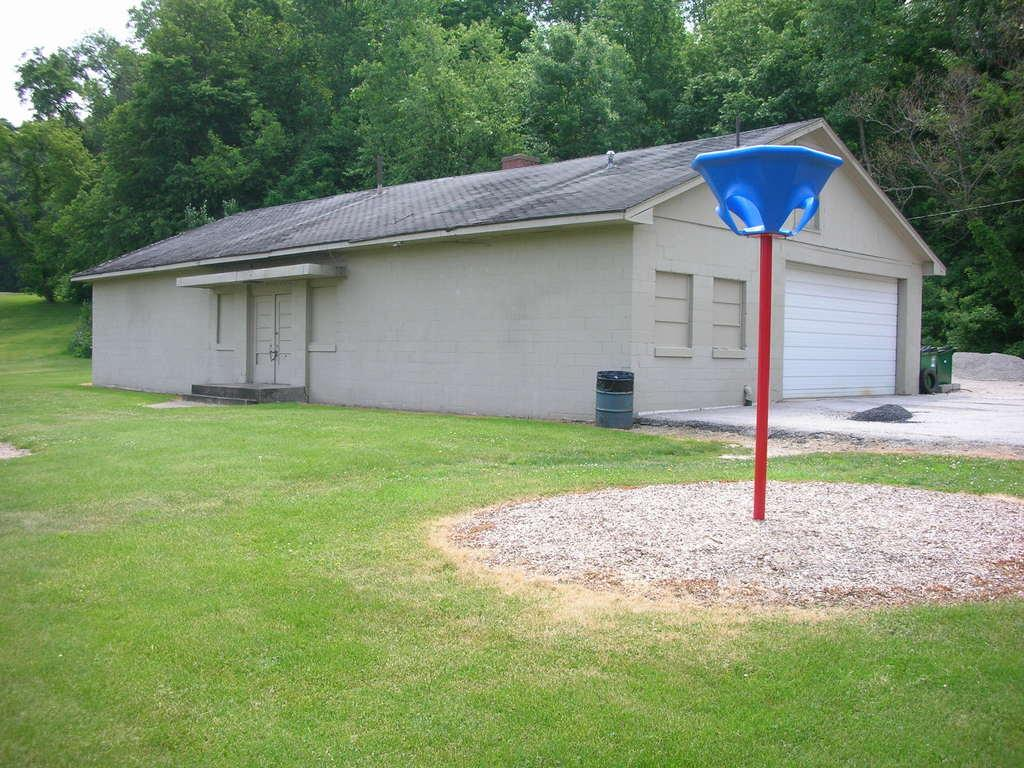What is located in the front of the image? There is a house and a pole in the front of the image. What type of vegetation is present in the front of the image? Grass is present in the front of the image. What objects can be seen in the front of the image? There are objects in the front of the image. What is visible in the background of the image? Trees and the sky are visible in the background of the image. How is the land covered in the image? The land is covered with grass. Where is the afterthought shop located in the image? There is no mention of an afterthought shop in the image. How many dogs can be seen playing with the grass in the image? There are no dogs present in the image. 